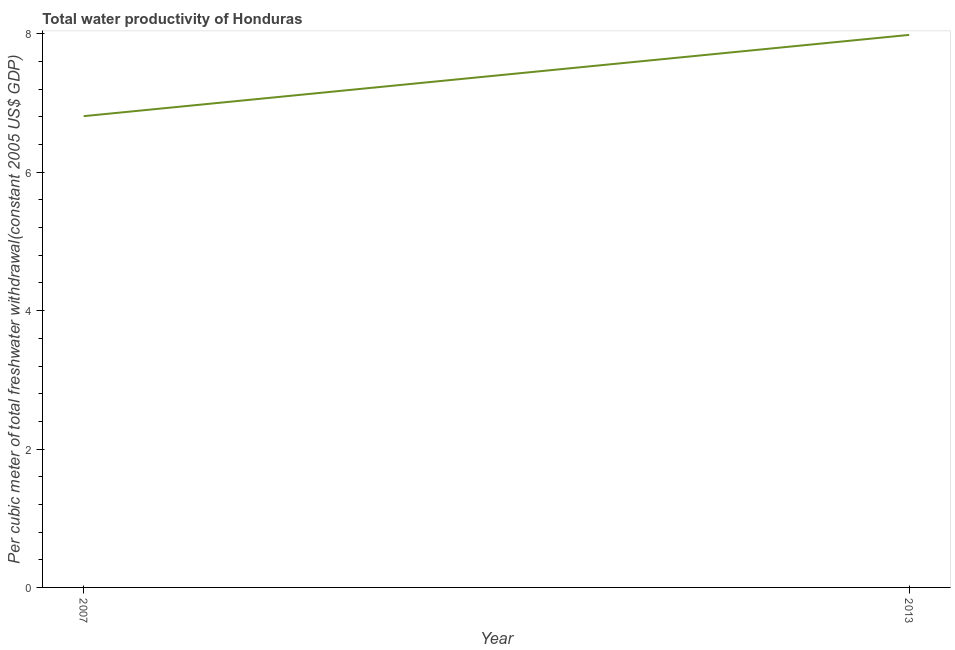What is the total water productivity in 2013?
Keep it short and to the point. 7.99. Across all years, what is the maximum total water productivity?
Offer a very short reply. 7.99. Across all years, what is the minimum total water productivity?
Your answer should be very brief. 6.81. In which year was the total water productivity maximum?
Offer a terse response. 2013. What is the sum of the total water productivity?
Give a very brief answer. 14.8. What is the difference between the total water productivity in 2007 and 2013?
Keep it short and to the point. -1.17. What is the average total water productivity per year?
Give a very brief answer. 7.4. What is the median total water productivity?
Make the answer very short. 7.4. In how many years, is the total water productivity greater than 5.6 US$?
Keep it short and to the point. 2. What is the ratio of the total water productivity in 2007 to that in 2013?
Provide a short and direct response. 0.85. Is the total water productivity in 2007 less than that in 2013?
Your answer should be very brief. Yes. How many years are there in the graph?
Provide a succinct answer. 2. Does the graph contain any zero values?
Your response must be concise. No. Does the graph contain grids?
Provide a succinct answer. No. What is the title of the graph?
Your answer should be very brief. Total water productivity of Honduras. What is the label or title of the X-axis?
Keep it short and to the point. Year. What is the label or title of the Y-axis?
Your response must be concise. Per cubic meter of total freshwater withdrawal(constant 2005 US$ GDP). What is the Per cubic meter of total freshwater withdrawal(constant 2005 US$ GDP) in 2007?
Make the answer very short. 6.81. What is the Per cubic meter of total freshwater withdrawal(constant 2005 US$ GDP) of 2013?
Provide a succinct answer. 7.99. What is the difference between the Per cubic meter of total freshwater withdrawal(constant 2005 US$ GDP) in 2007 and 2013?
Keep it short and to the point. -1.17. What is the ratio of the Per cubic meter of total freshwater withdrawal(constant 2005 US$ GDP) in 2007 to that in 2013?
Offer a very short reply. 0.85. 